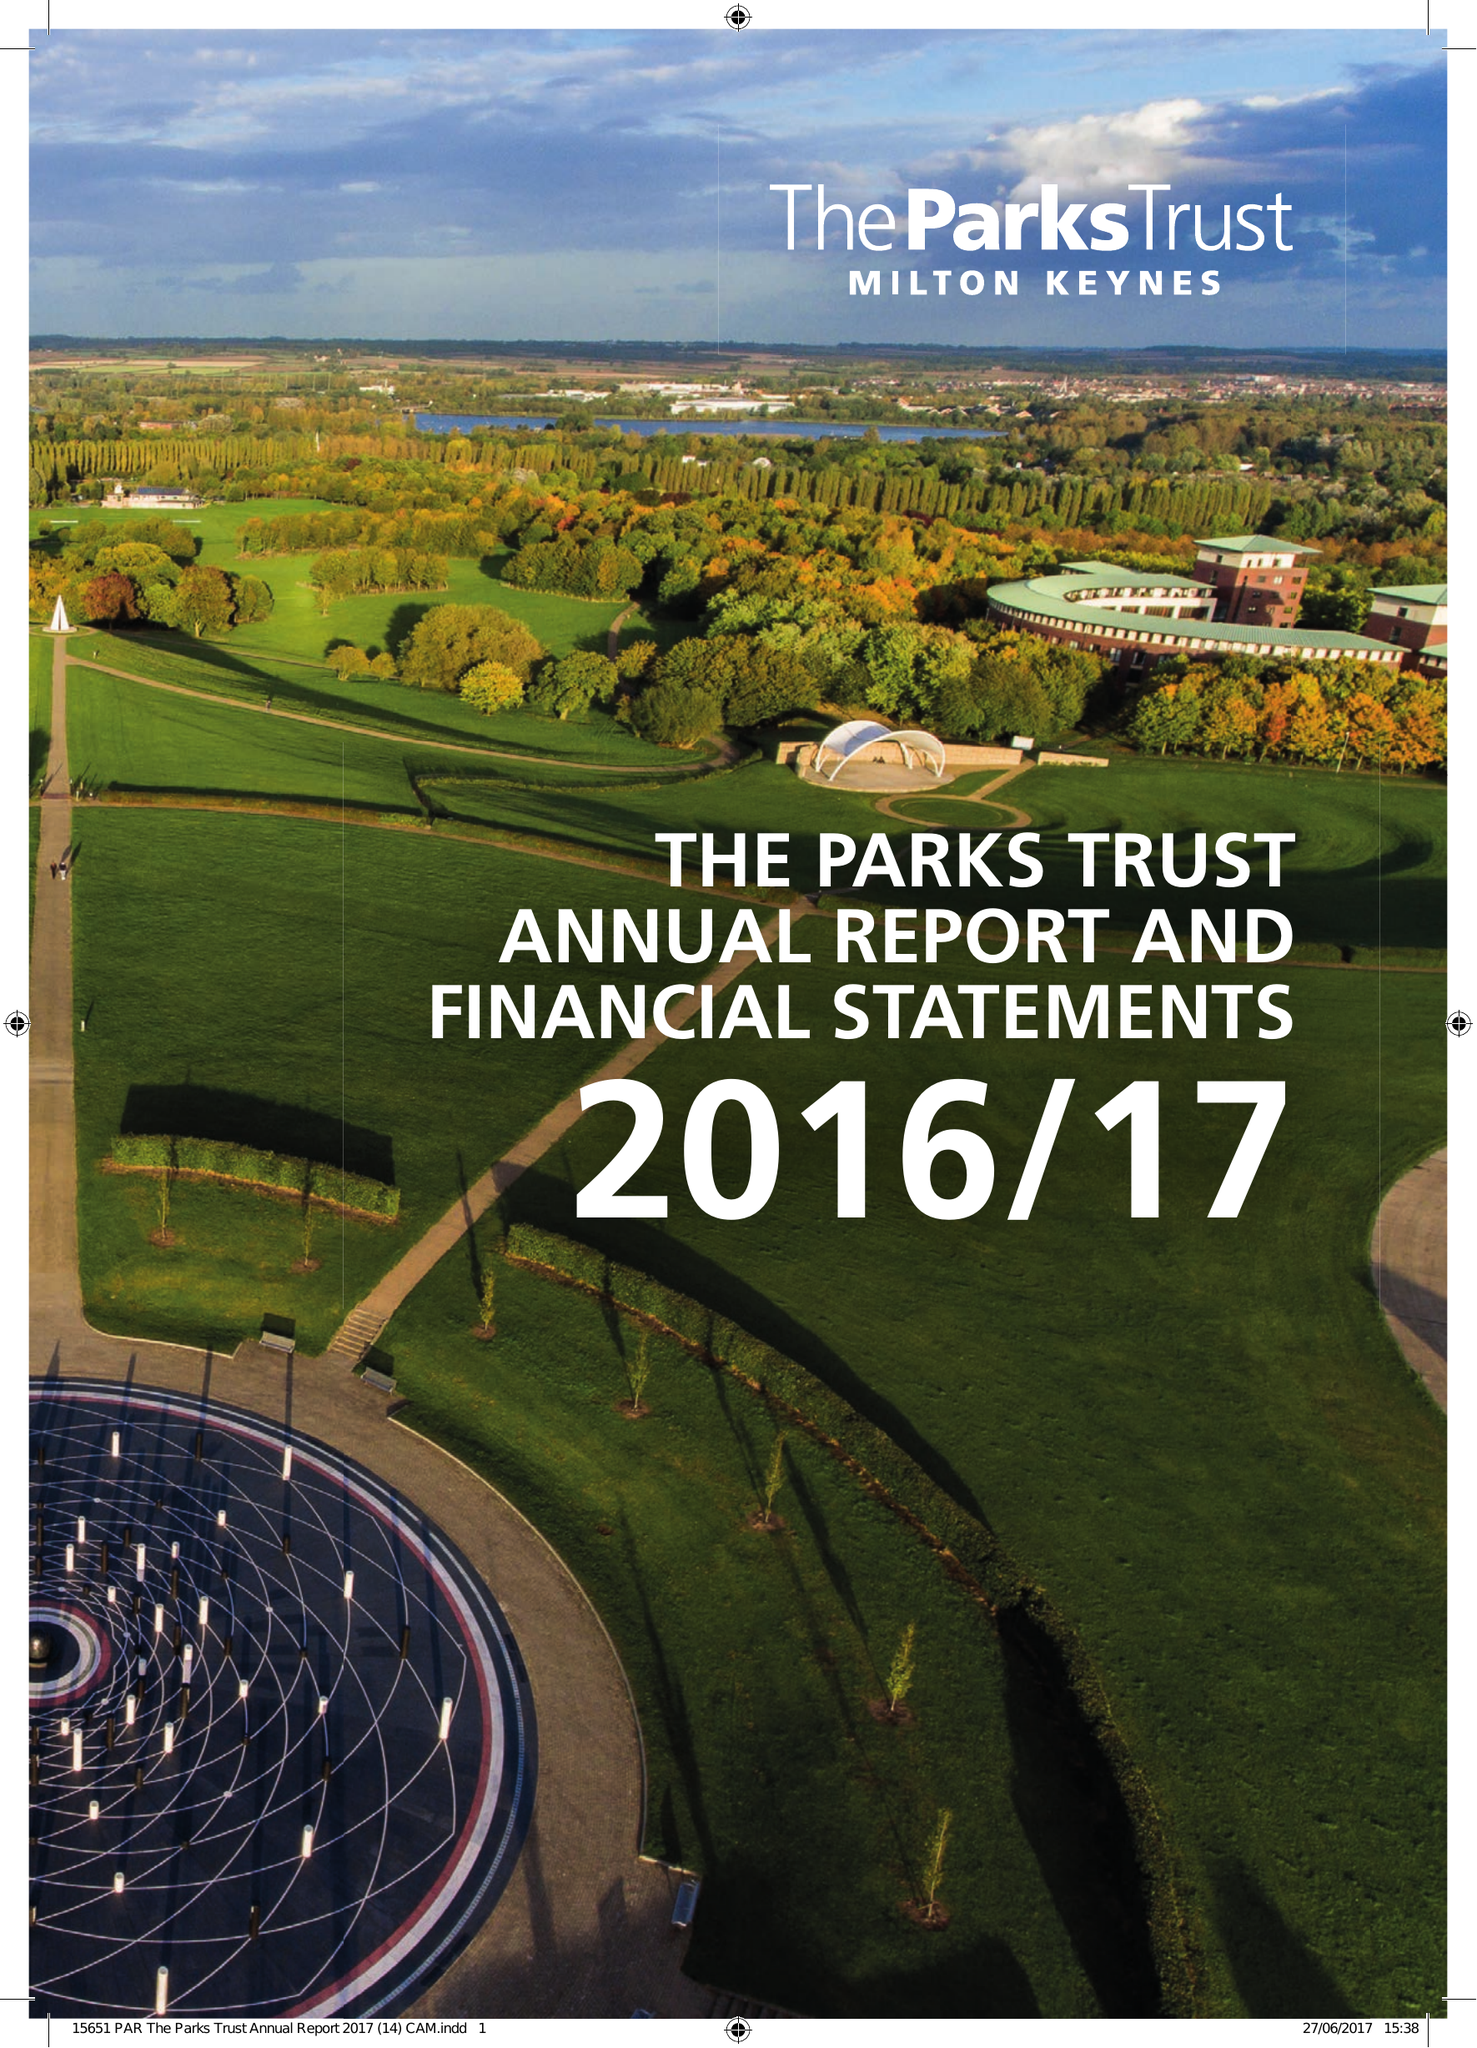What is the value for the address__street_line?
Answer the question using a single word or phrase. 1300 SILBURY BOULEVARD 